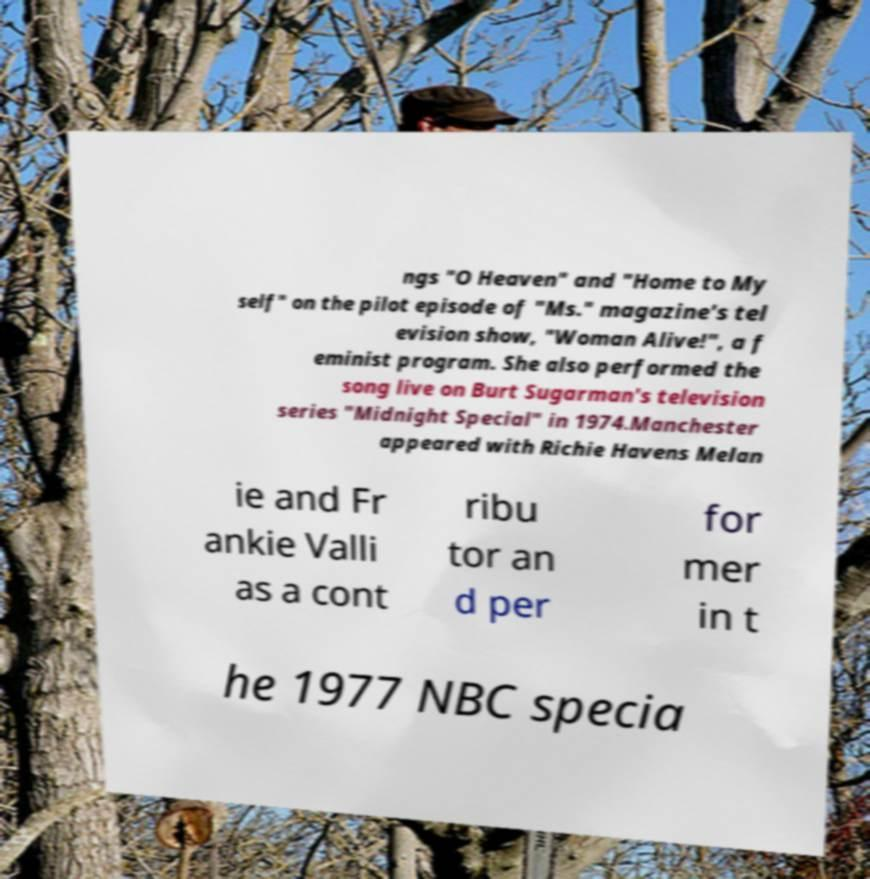Can you accurately transcribe the text from the provided image for me? ngs "O Heaven" and "Home to My self" on the pilot episode of "Ms." magazine's tel evision show, "Woman Alive!", a f eminist program. She also performed the song live on Burt Sugarman's television series "Midnight Special" in 1974.Manchester appeared with Richie Havens Melan ie and Fr ankie Valli as a cont ribu tor an d per for mer in t he 1977 NBC specia 